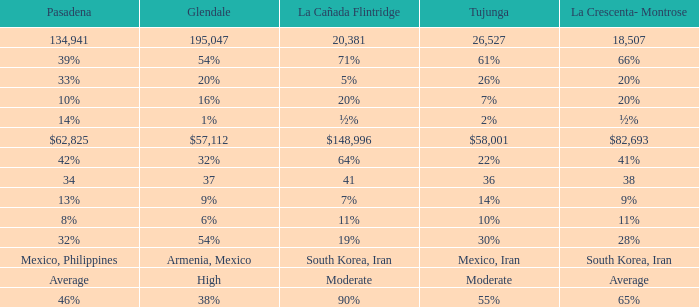When La Crescenta-Montrose has 66%, what is Tujunga? 61%. 